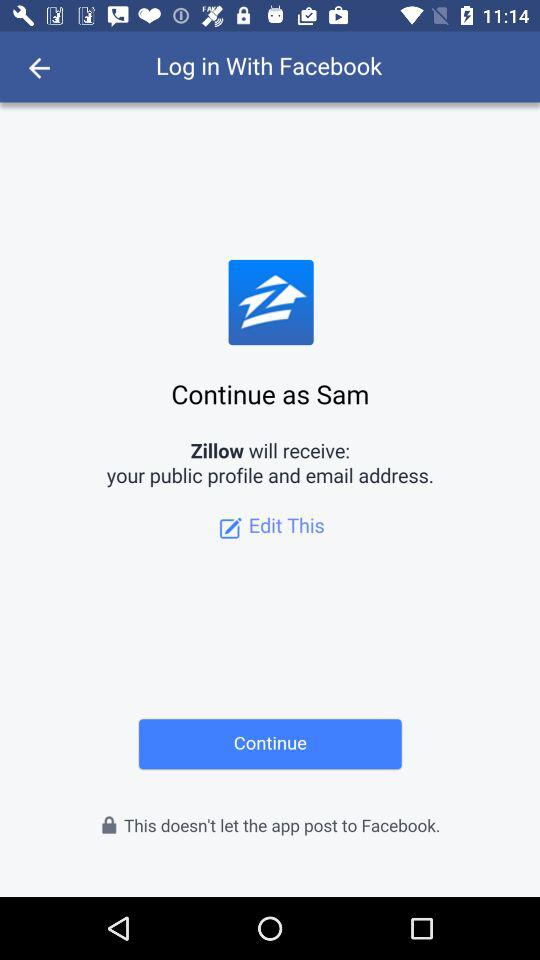Who will receive the details? The application "Zillow" will receive the details. 